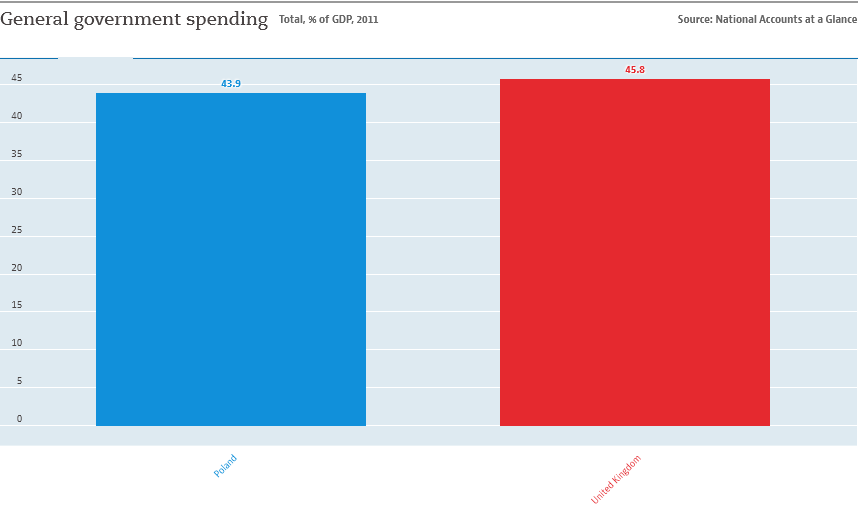Point out several critical features in this image. The sum of two bars is 89.7.. The blue bar represents Poland. 